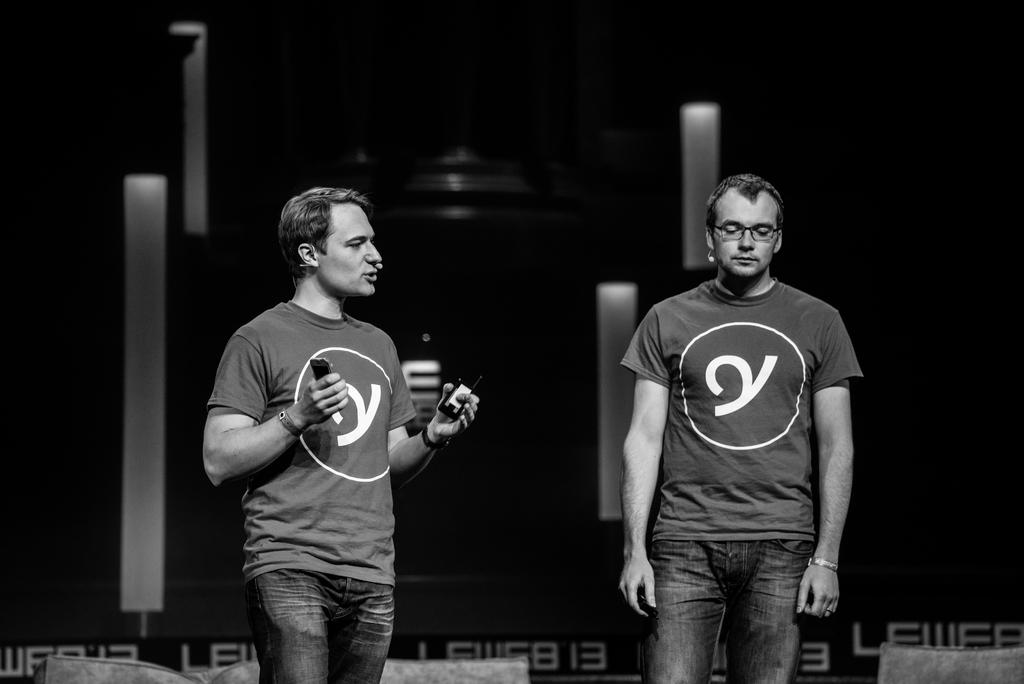How many people are in the foreground of the image? There are two men in the foreground of the image. What are the men doing in the image? The men are standing in the image. What are the men holding in their hands? The men are holding objects in their hands. What can be seen in the background of the image? There are cushions in the background of the image. Can you describe the objects in the background that are not clear? Unfortunately, the remaining objects in the background are not clear enough to describe. Can you see any planes flying in the image? There are no planes visible in the image. Is there a coach visible in the image? There is no coach present in the image. Is there a cave in the image? There is no cave present in the image. 